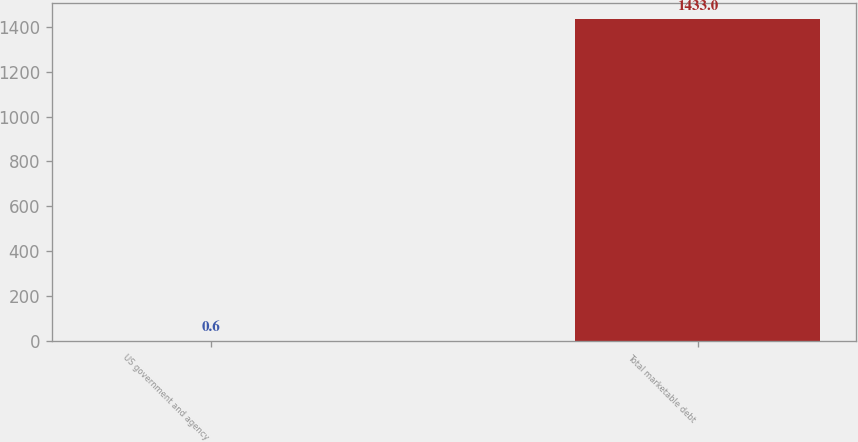<chart> <loc_0><loc_0><loc_500><loc_500><bar_chart><fcel>US government and agency<fcel>Total marketable debt<nl><fcel>0.6<fcel>1433<nl></chart> 